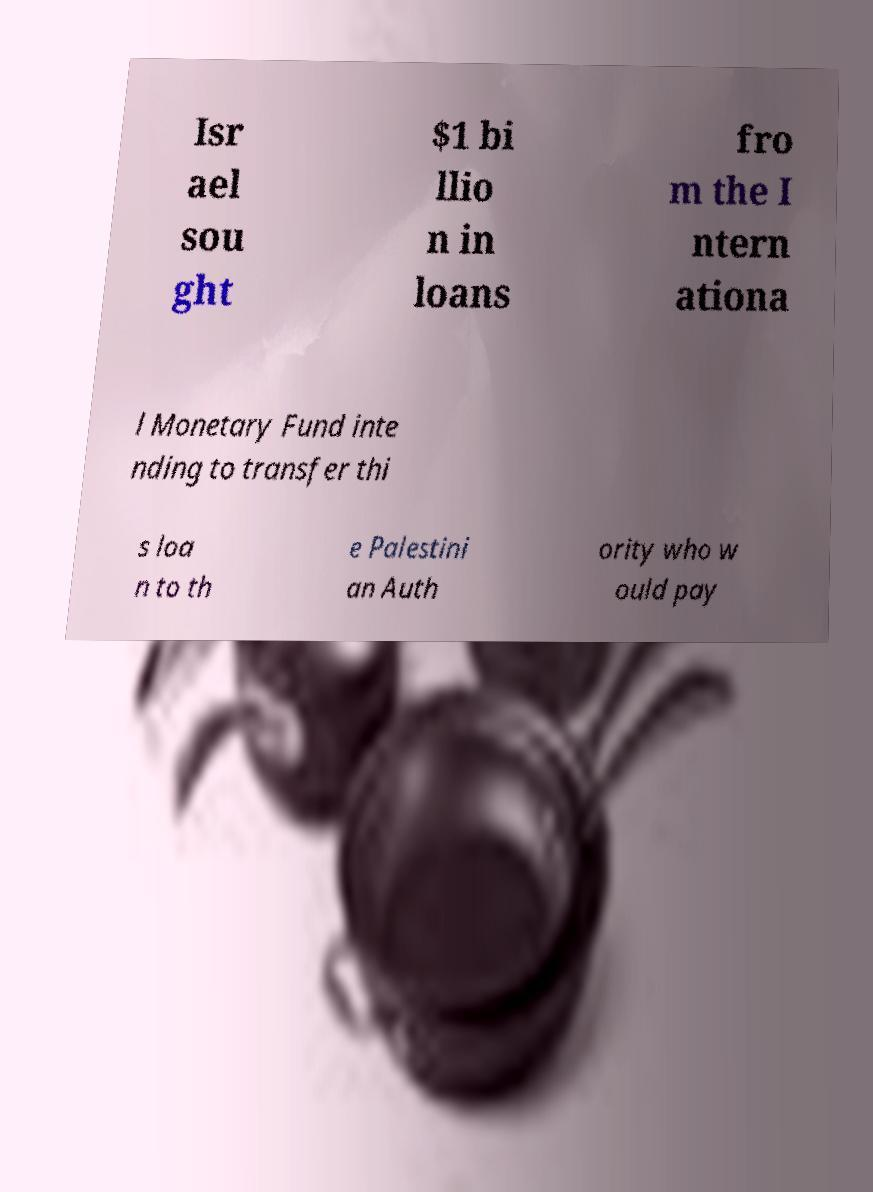There's text embedded in this image that I need extracted. Can you transcribe it verbatim? Isr ael sou ght $1 bi llio n in loans fro m the I ntern ationa l Monetary Fund inte nding to transfer thi s loa n to th e Palestini an Auth ority who w ould pay 